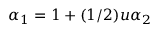Convert formula to latex. <formula><loc_0><loc_0><loc_500><loc_500>\alpha _ { 1 } = 1 + ( 1 / 2 ) u \alpha _ { 2 }</formula> 